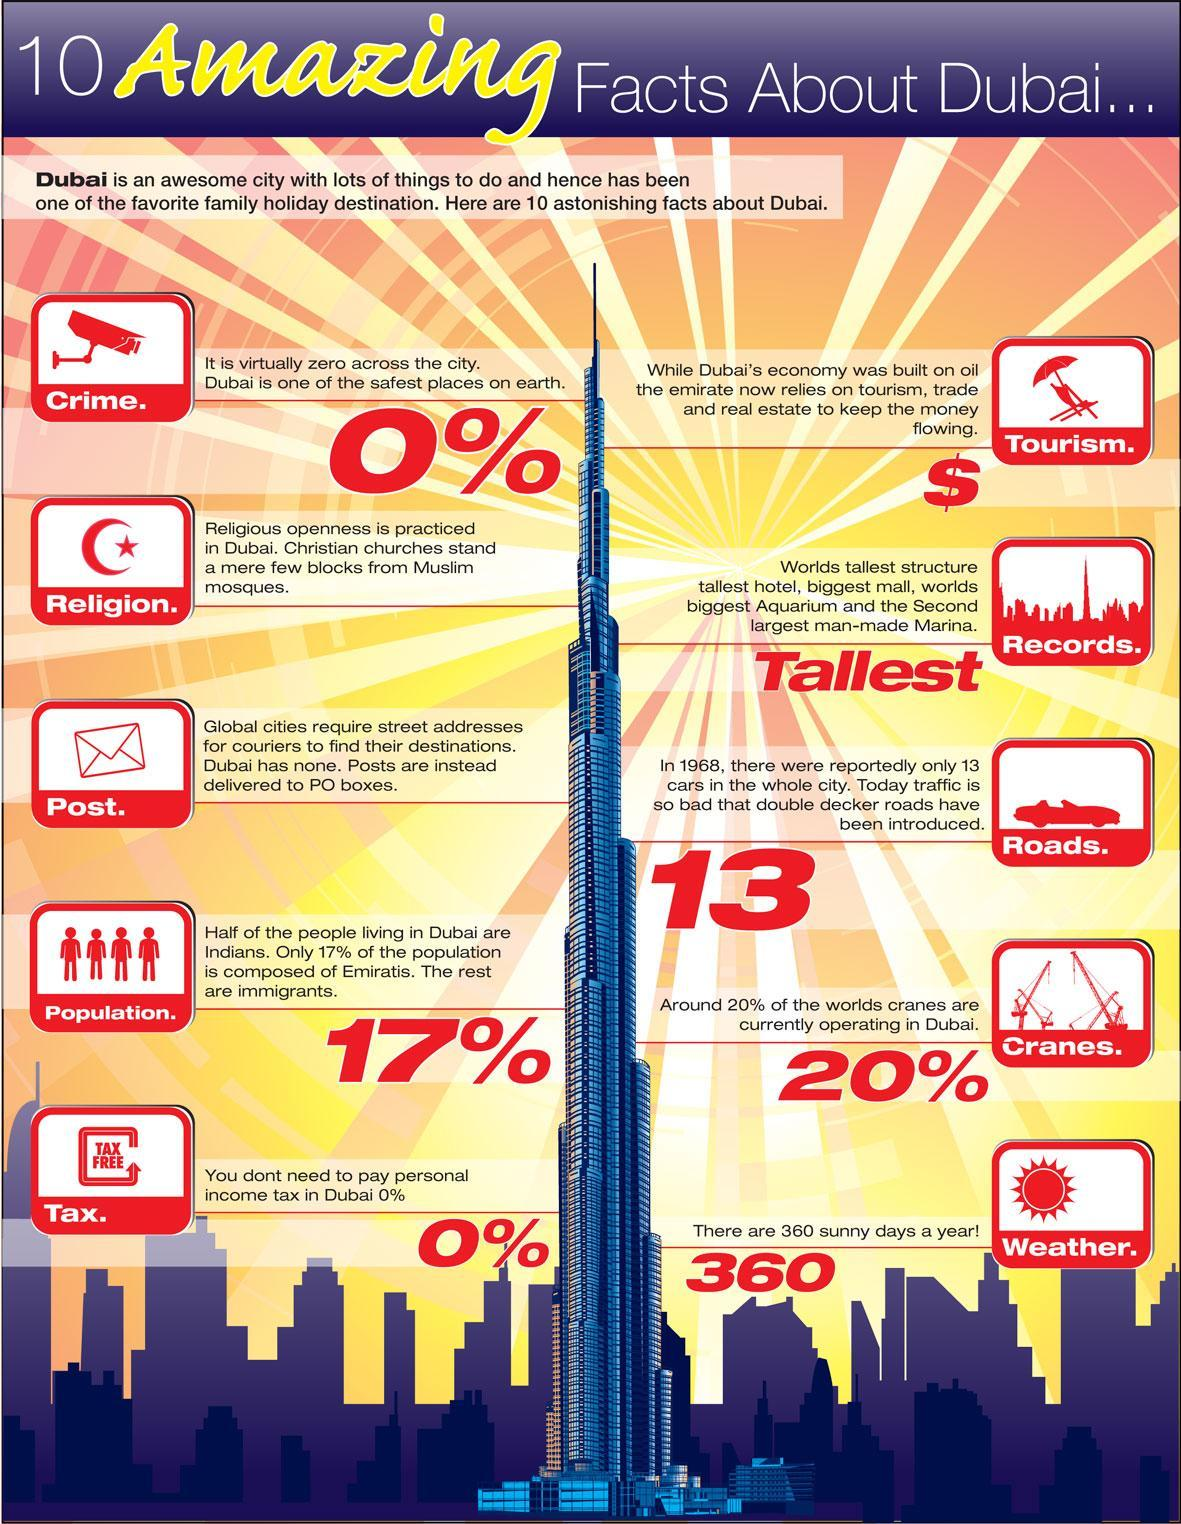which city has the world's biggest aquarium?
Answer the question with a short phrase. Dubai What is 0% in Dubai? crime,personal income tax 